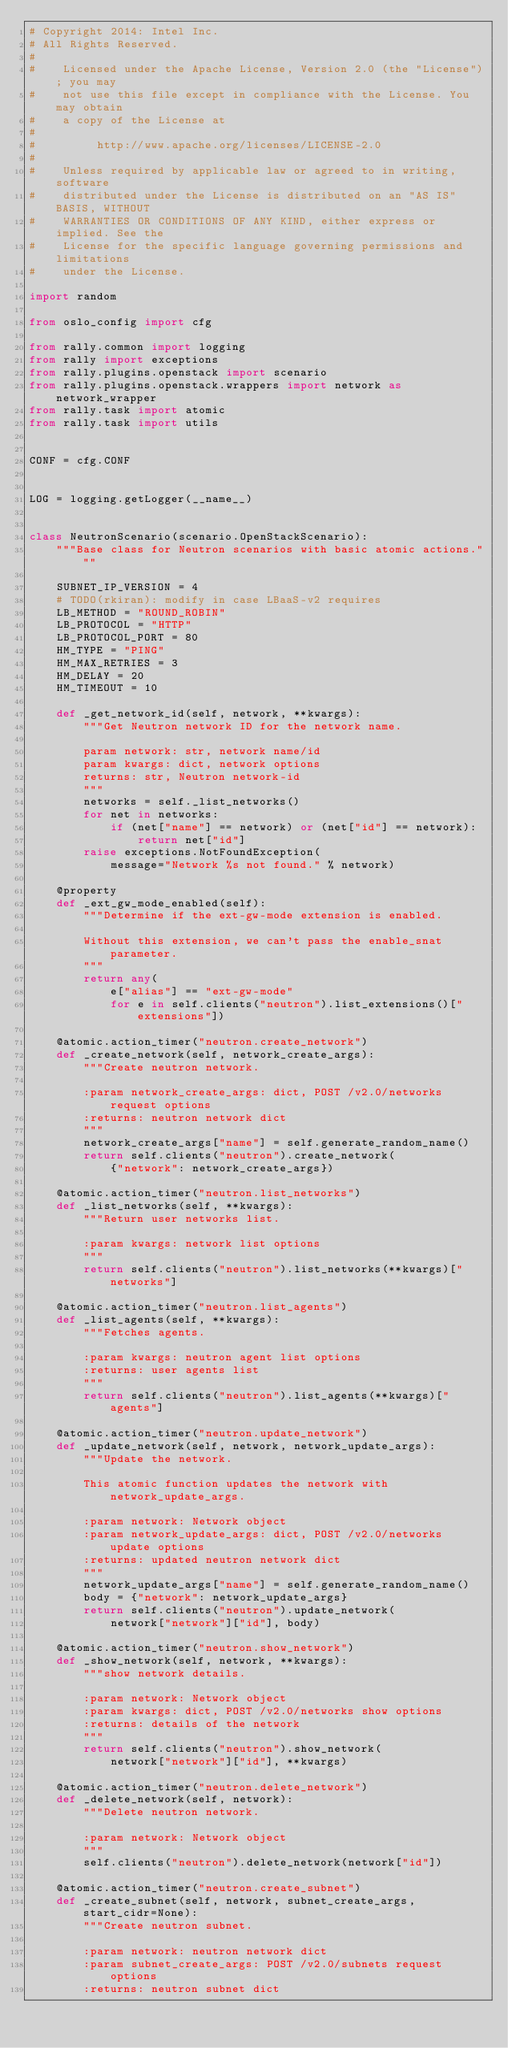Convert code to text. <code><loc_0><loc_0><loc_500><loc_500><_Python_># Copyright 2014: Intel Inc.
# All Rights Reserved.
#
#    Licensed under the Apache License, Version 2.0 (the "License"); you may
#    not use this file except in compliance with the License. You may obtain
#    a copy of the License at
#
#         http://www.apache.org/licenses/LICENSE-2.0
#
#    Unless required by applicable law or agreed to in writing, software
#    distributed under the License is distributed on an "AS IS" BASIS, WITHOUT
#    WARRANTIES OR CONDITIONS OF ANY KIND, either express or implied. See the
#    License for the specific language governing permissions and limitations
#    under the License.

import random

from oslo_config import cfg

from rally.common import logging
from rally import exceptions
from rally.plugins.openstack import scenario
from rally.plugins.openstack.wrappers import network as network_wrapper
from rally.task import atomic
from rally.task import utils


CONF = cfg.CONF


LOG = logging.getLogger(__name__)


class NeutronScenario(scenario.OpenStackScenario):
    """Base class for Neutron scenarios with basic atomic actions."""

    SUBNET_IP_VERSION = 4
    # TODO(rkiran): modify in case LBaaS-v2 requires
    LB_METHOD = "ROUND_ROBIN"
    LB_PROTOCOL = "HTTP"
    LB_PROTOCOL_PORT = 80
    HM_TYPE = "PING"
    HM_MAX_RETRIES = 3
    HM_DELAY = 20
    HM_TIMEOUT = 10

    def _get_network_id(self, network, **kwargs):
        """Get Neutron network ID for the network name.

        param network: str, network name/id
        param kwargs: dict, network options
        returns: str, Neutron network-id
        """
        networks = self._list_networks()
        for net in networks:
            if (net["name"] == network) or (net["id"] == network):
                return net["id"]
        raise exceptions.NotFoundException(
            message="Network %s not found." % network)

    @property
    def _ext_gw_mode_enabled(self):
        """Determine if the ext-gw-mode extension is enabled.

        Without this extension, we can't pass the enable_snat parameter.
        """
        return any(
            e["alias"] == "ext-gw-mode"
            for e in self.clients("neutron").list_extensions()["extensions"])

    @atomic.action_timer("neutron.create_network")
    def _create_network(self, network_create_args):
        """Create neutron network.

        :param network_create_args: dict, POST /v2.0/networks request options
        :returns: neutron network dict
        """
        network_create_args["name"] = self.generate_random_name()
        return self.clients("neutron").create_network(
            {"network": network_create_args})

    @atomic.action_timer("neutron.list_networks")
    def _list_networks(self, **kwargs):
        """Return user networks list.

        :param kwargs: network list options
        """
        return self.clients("neutron").list_networks(**kwargs)["networks"]

    @atomic.action_timer("neutron.list_agents")
    def _list_agents(self, **kwargs):
        """Fetches agents.

        :param kwargs: neutron agent list options
        :returns: user agents list
        """
        return self.clients("neutron").list_agents(**kwargs)["agents"]

    @atomic.action_timer("neutron.update_network")
    def _update_network(self, network, network_update_args):
        """Update the network.

        This atomic function updates the network with network_update_args.

        :param network: Network object
        :param network_update_args: dict, POST /v2.0/networks update options
        :returns: updated neutron network dict
        """
        network_update_args["name"] = self.generate_random_name()
        body = {"network": network_update_args}
        return self.clients("neutron").update_network(
            network["network"]["id"], body)

    @atomic.action_timer("neutron.show_network")
    def _show_network(self, network, **kwargs):
        """show network details.

        :param network: Network object
        :param kwargs: dict, POST /v2.0/networks show options
        :returns: details of the network
        """
        return self.clients("neutron").show_network(
            network["network"]["id"], **kwargs)

    @atomic.action_timer("neutron.delete_network")
    def _delete_network(self, network):
        """Delete neutron network.

        :param network: Network object
        """
        self.clients("neutron").delete_network(network["id"])

    @atomic.action_timer("neutron.create_subnet")
    def _create_subnet(self, network, subnet_create_args, start_cidr=None):
        """Create neutron subnet.

        :param network: neutron network dict
        :param subnet_create_args: POST /v2.0/subnets request options
        :returns: neutron subnet dict</code> 